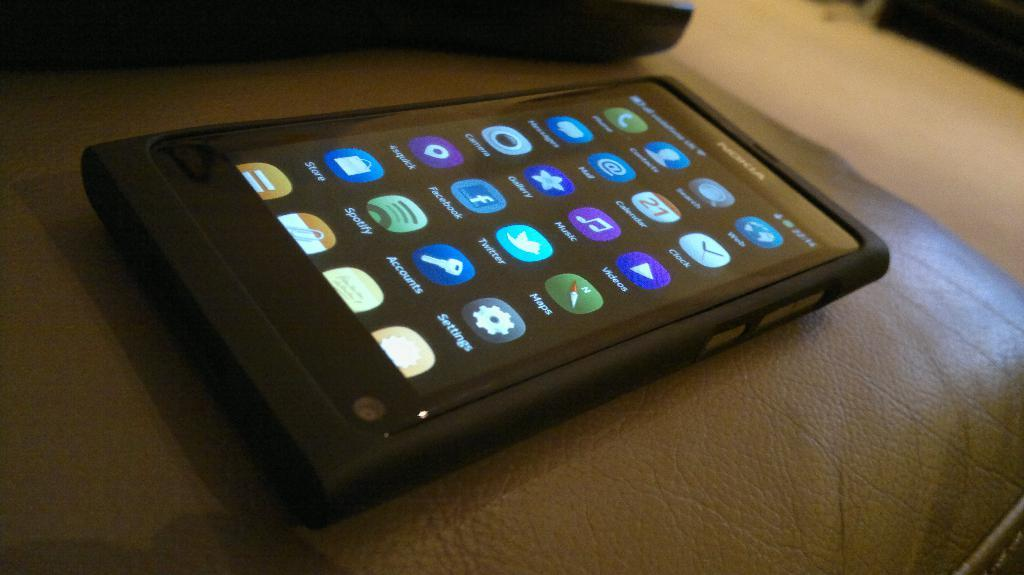<image>
Provide a brief description of the given image. A black Nokia smart phone resting on a leather couch. 